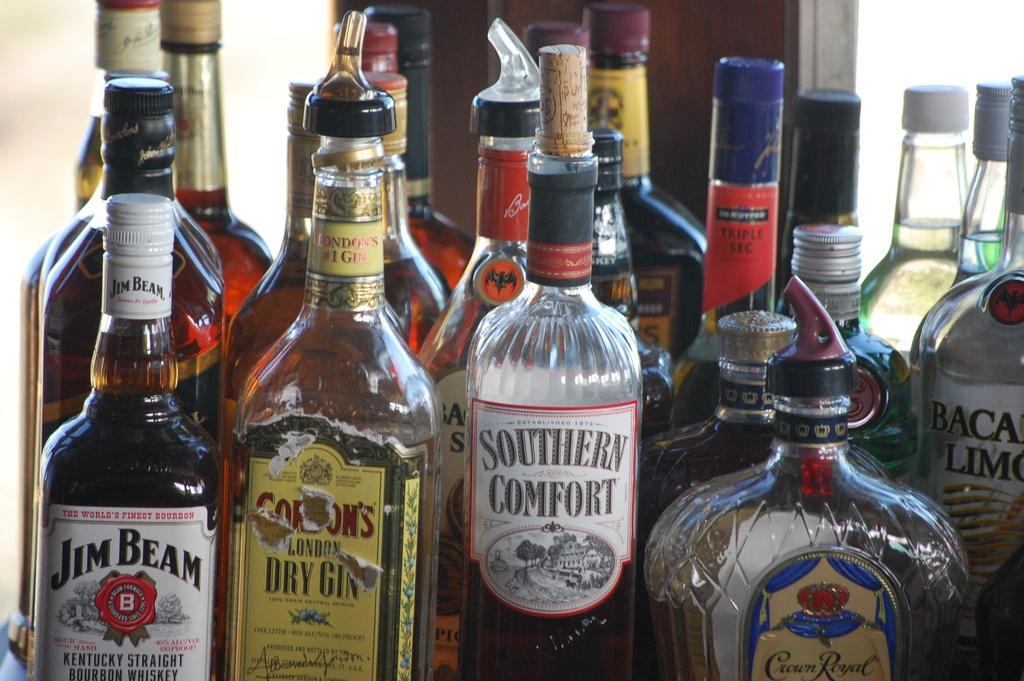What objects are present in the image? There are bottles in the image. Can you describe the text on the bottles? The text "JEAM BEAM" is written on one of the bottles, and the text "SOUTHERN COMFORT" is written on another bottle. What type of basin is visible in the image? There is no basin present in the image; it only features bottles with text. Can you describe the sticks used to stir the drinks in the image? There are no sticks visible in the image; only the bottles and their text are present. 